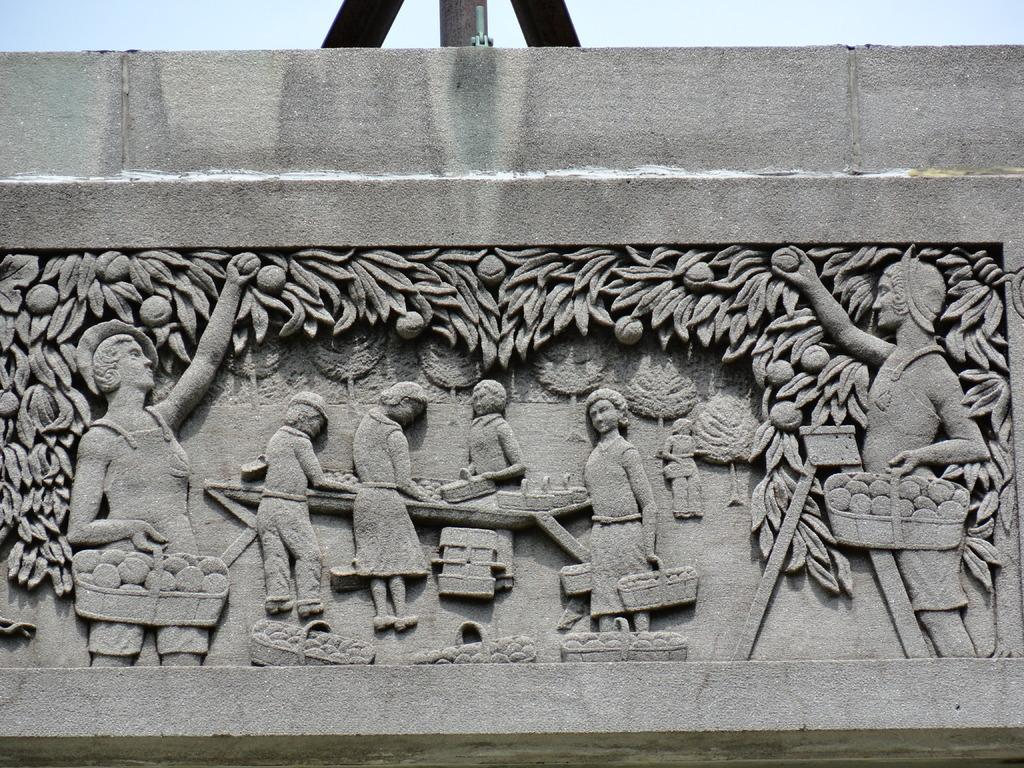What type of artwork can be seen in the image? There are sculptures in the image. Where are the sculptures located? The sculptures are engraved on a wall. Which direction does the cat face in the image? There is no cat present in the image. 